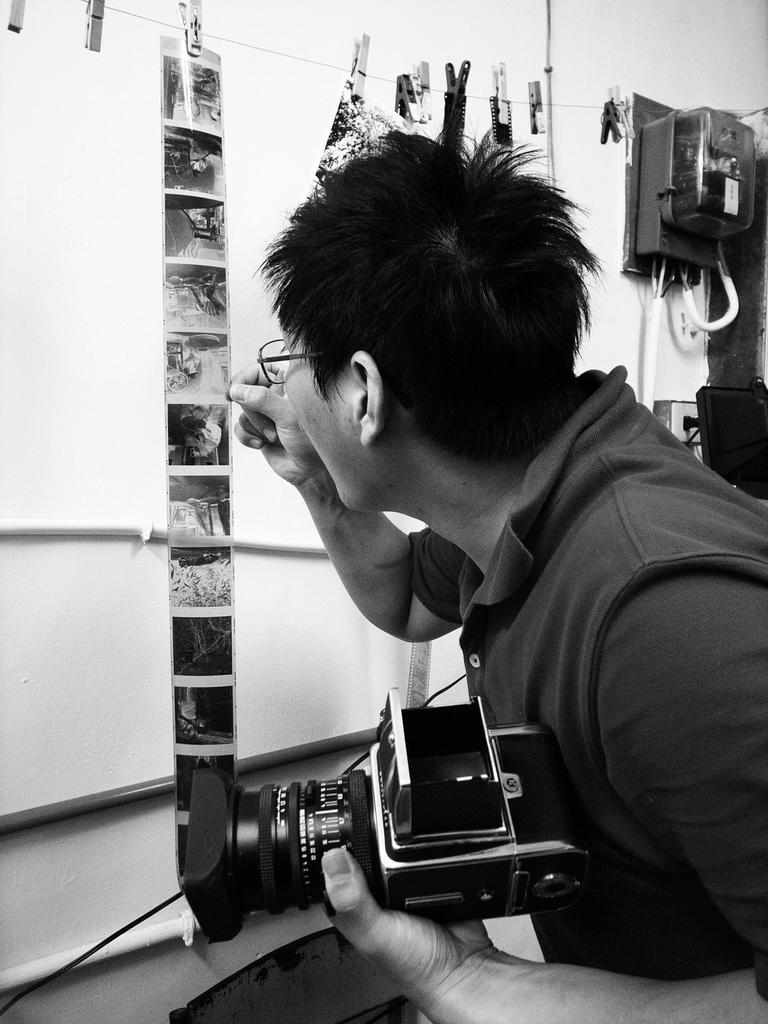What is the man in the image doing with his left hand? The man is holding a camera in his left hand. What is the man in the image doing with his right hand? The man is observing a picture in his right hand. Can you describe any objects in the top right corner of the image? There is an electrical box in the top right corner of the image. What type of songs is the man singing in the image? There is no indication in the image that the man is singing any songs. What nation is the man representing in the image? There is no information about the man's nationality or any representation of a nation in the image. 